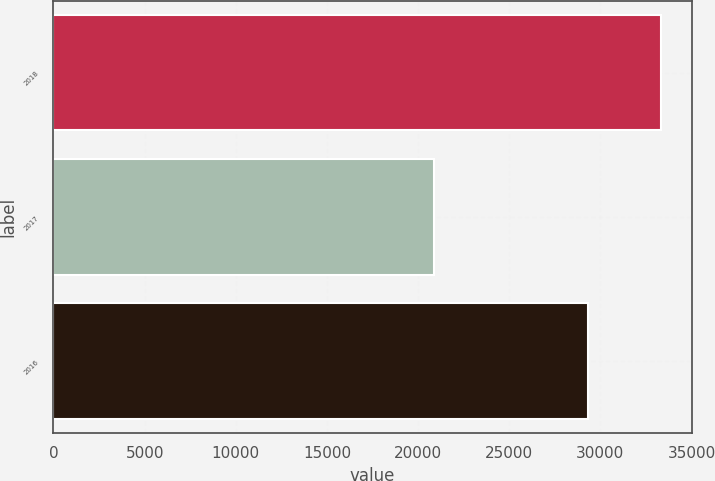<chart> <loc_0><loc_0><loc_500><loc_500><bar_chart><fcel>2018<fcel>2017<fcel>2016<nl><fcel>33337<fcel>20901<fcel>29315<nl></chart> 